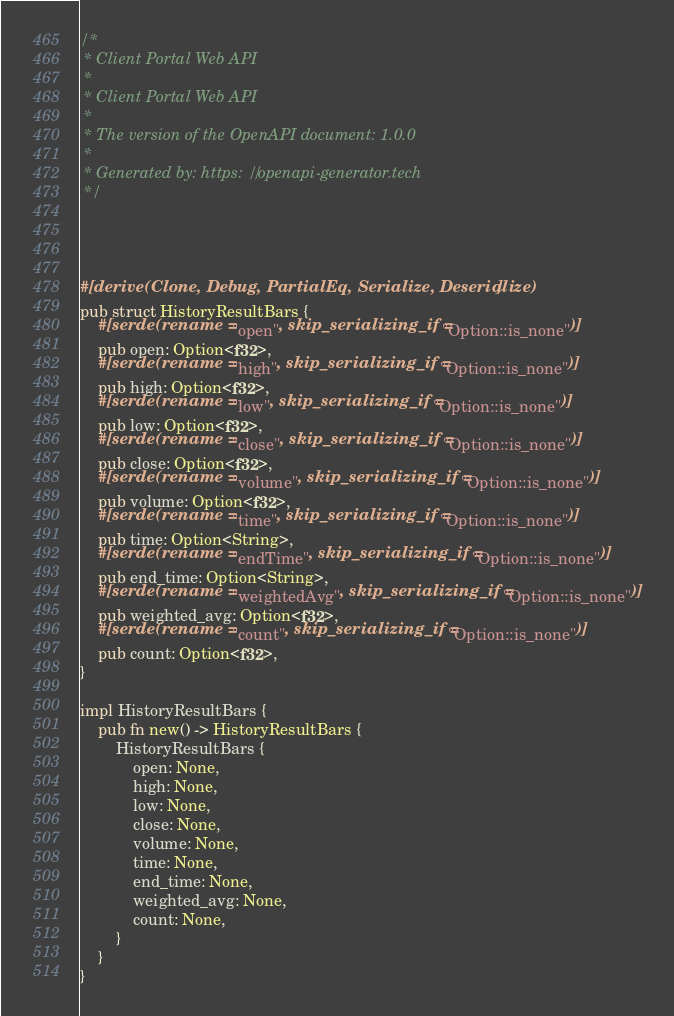Convert code to text. <code><loc_0><loc_0><loc_500><loc_500><_Rust_>/*
 * Client Portal Web API
 *
 * Client Portal Web API
 *
 * The version of the OpenAPI document: 1.0.0
 * 
 * Generated by: https://openapi-generator.tech
 */




#[derive(Clone, Debug, PartialEq, Serialize, Deserialize)]
pub struct HistoryResultBars {
    #[serde(rename = "open", skip_serializing_if = "Option::is_none")]
    pub open: Option<f32>,
    #[serde(rename = "high", skip_serializing_if = "Option::is_none")]
    pub high: Option<f32>,
    #[serde(rename = "low", skip_serializing_if = "Option::is_none")]
    pub low: Option<f32>,
    #[serde(rename = "close", skip_serializing_if = "Option::is_none")]
    pub close: Option<f32>,
    #[serde(rename = "volume", skip_serializing_if = "Option::is_none")]
    pub volume: Option<f32>,
    #[serde(rename = "time", skip_serializing_if = "Option::is_none")]
    pub time: Option<String>,
    #[serde(rename = "endTime", skip_serializing_if = "Option::is_none")]
    pub end_time: Option<String>,
    #[serde(rename = "weightedAvg", skip_serializing_if = "Option::is_none")]
    pub weighted_avg: Option<f32>,
    #[serde(rename = "count", skip_serializing_if = "Option::is_none")]
    pub count: Option<f32>,
}

impl HistoryResultBars {
    pub fn new() -> HistoryResultBars {
        HistoryResultBars {
            open: None,
            high: None,
            low: None,
            close: None,
            volume: None,
            time: None,
            end_time: None,
            weighted_avg: None,
            count: None,
        }
    }
}


</code> 